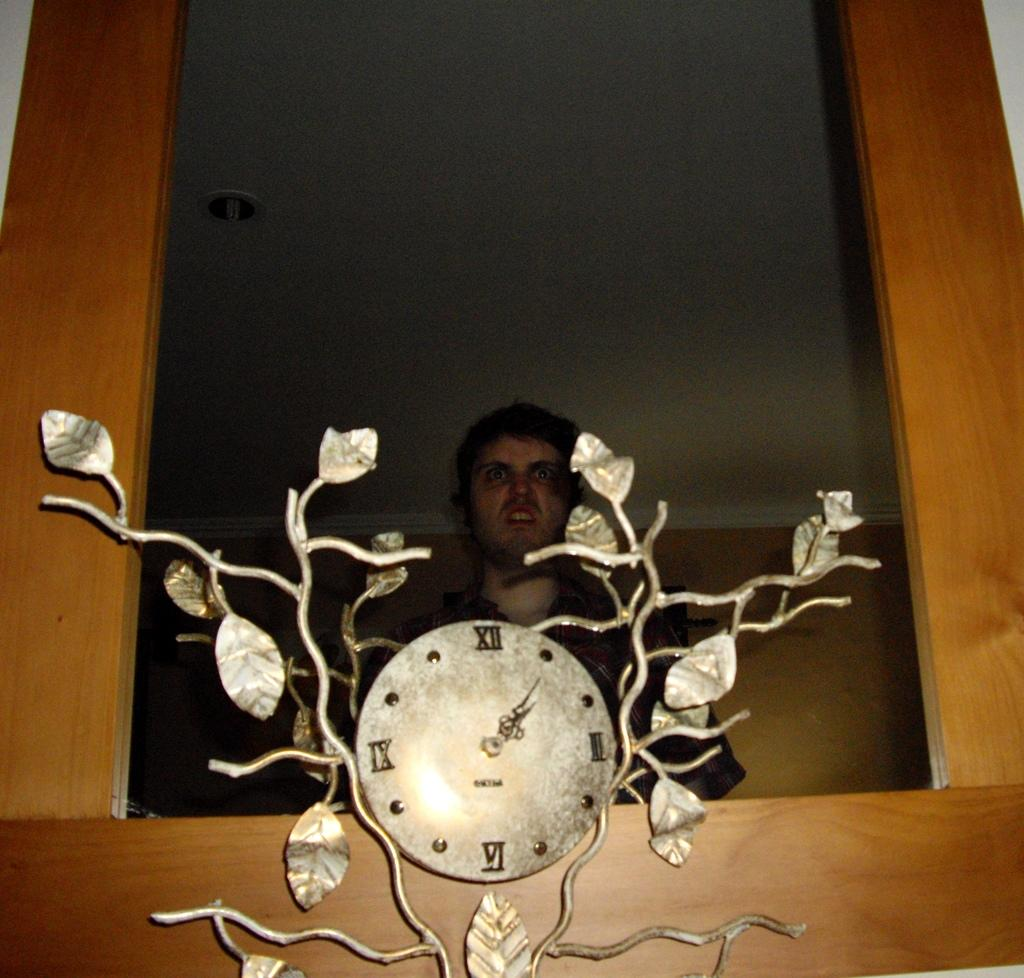Provide a one-sentence caption for the provided image. A small tree-themed clock contains four Roman numerals, including XII and VI. 